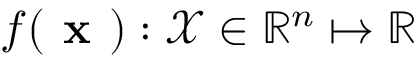Convert formula to latex. <formula><loc_0><loc_0><loc_500><loc_500>f ( x ) \colon \mathcal { X } \in \mathbb { R } ^ { n } \mapsto \mathbb { R }</formula> 